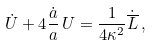<formula> <loc_0><loc_0><loc_500><loc_500>\dot { U } + 4 { \frac { \dot { a } } { a } } \, U = { \frac { 1 } { 4 \kappa ^ { 2 } } } \dot { \overline { L } } \, ,</formula> 